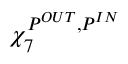<formula> <loc_0><loc_0><loc_500><loc_500>\chi _ { 7 } ^ { P ^ { O U T } , P ^ { I N } }</formula> 